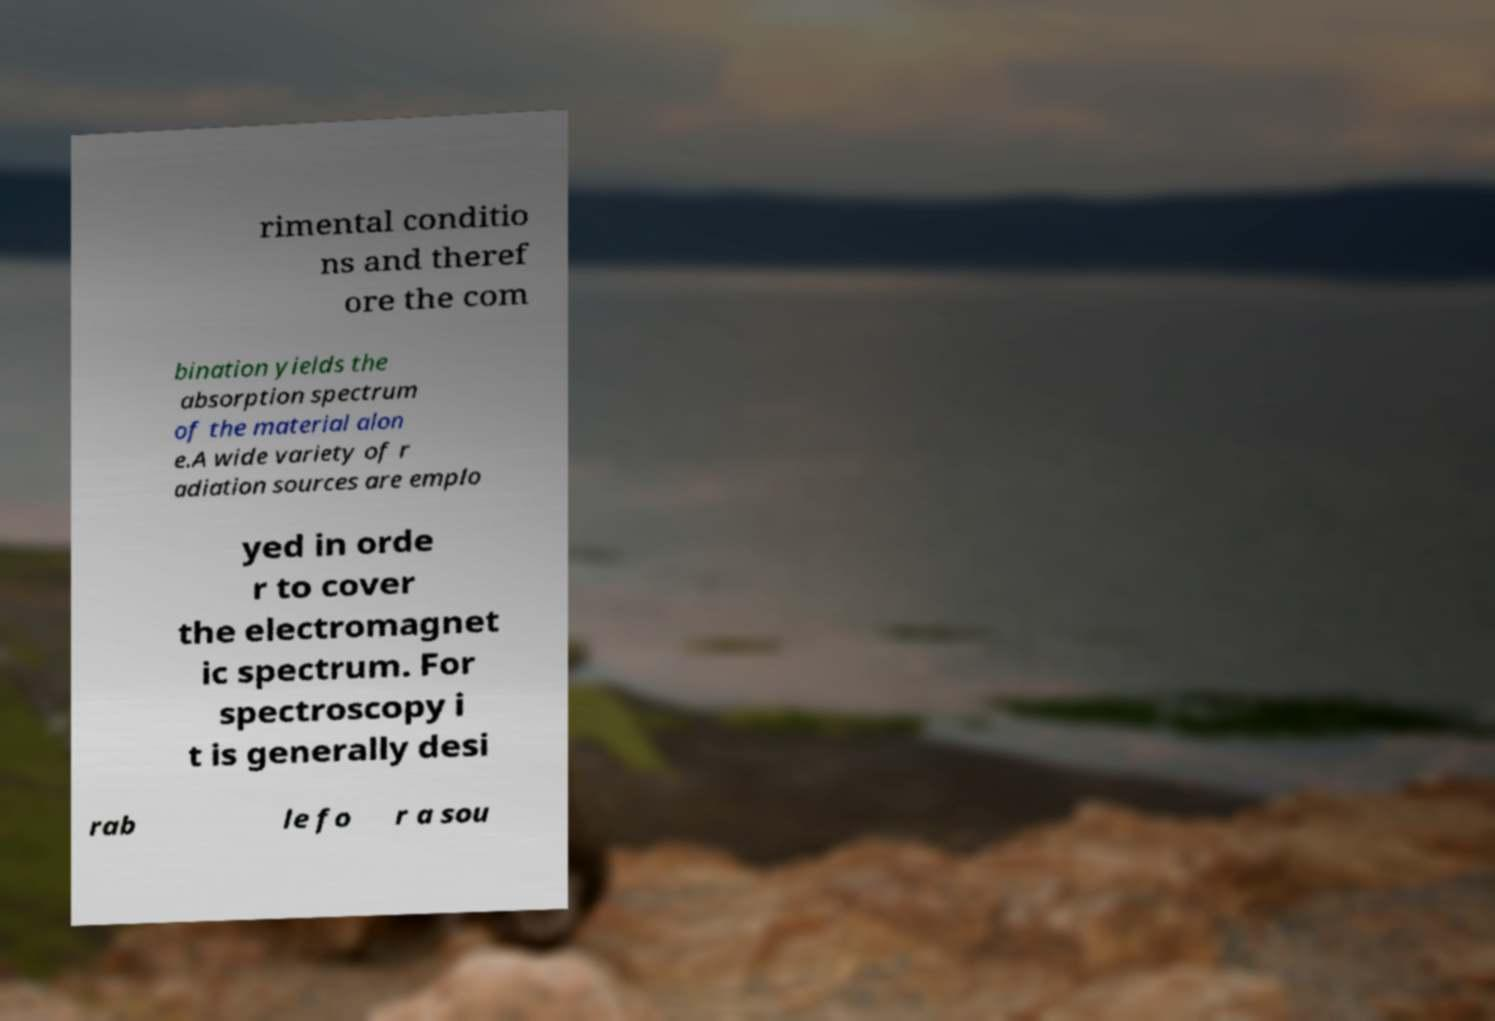I need the written content from this picture converted into text. Can you do that? rimental conditio ns and theref ore the com bination yields the absorption spectrum of the material alon e.A wide variety of r adiation sources are emplo yed in orde r to cover the electromagnet ic spectrum. For spectroscopy i t is generally desi rab le fo r a sou 